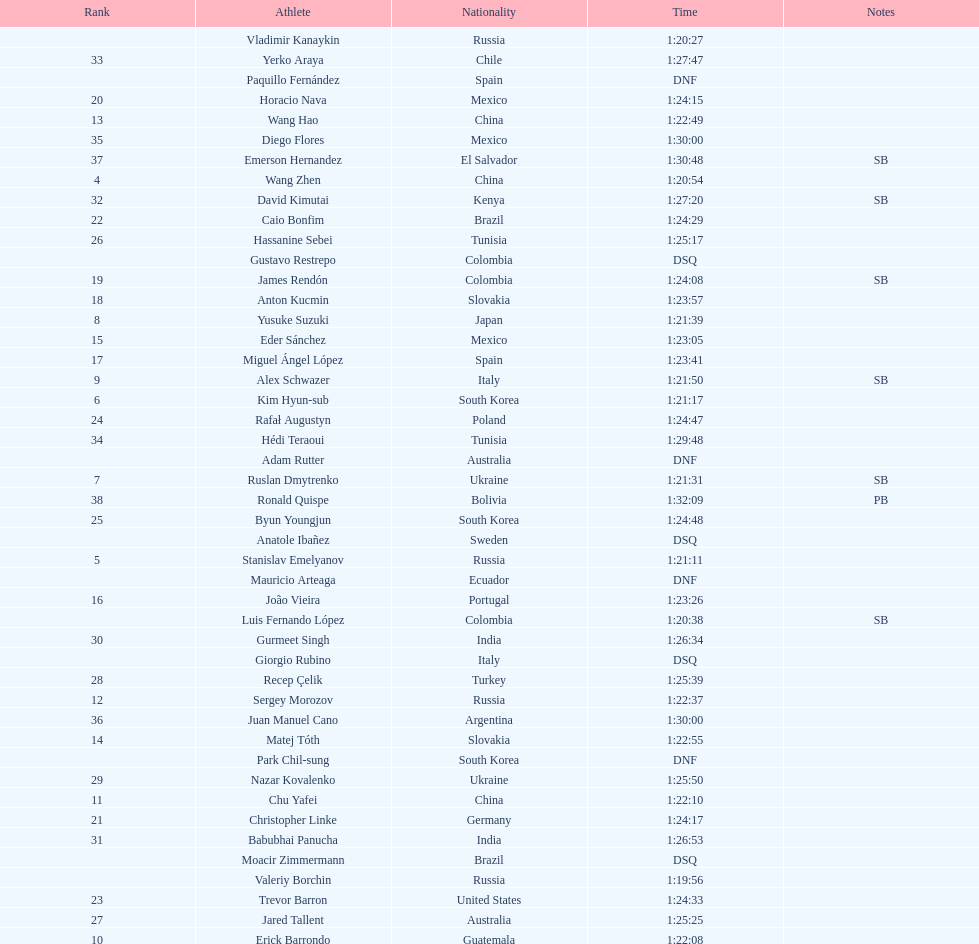How many russians finished at least 3rd in the 20km walk? 2. 